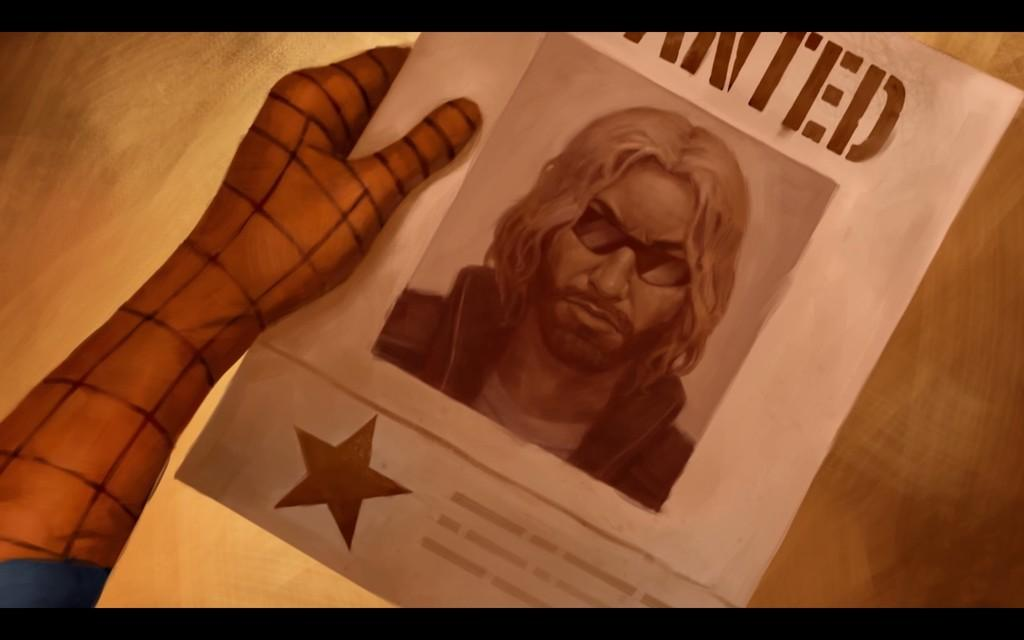<image>
Summarize the visual content of the image. A comic WANTED poster is being held by Spiderman. 